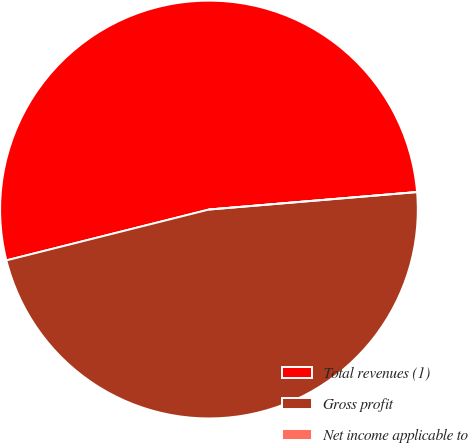Convert chart. <chart><loc_0><loc_0><loc_500><loc_500><pie_chart><fcel>Total revenues (1)<fcel>Gross profit<fcel>Net income applicable to<nl><fcel>52.58%<fcel>47.42%<fcel>0.0%<nl></chart> 